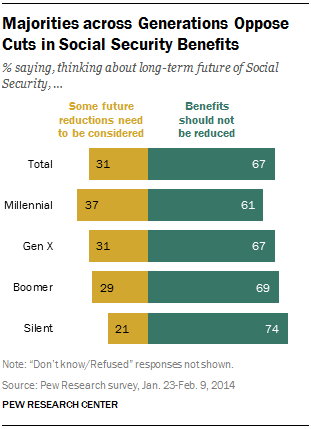Highlight a few significant elements in this photo. The yellow color represents a value that needs to be considered for future reductions. The generation with the greatest disparity between their opinions is the Silent Generation. 